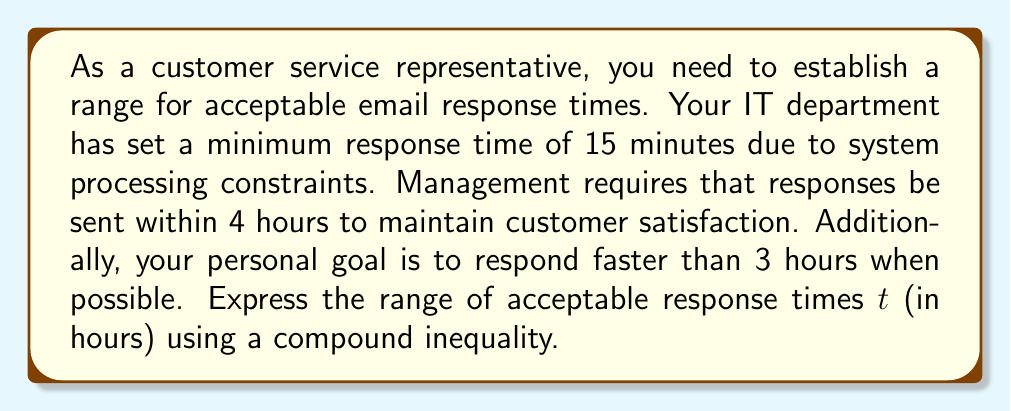Could you help me with this problem? To solve this problem, we need to convert all times to hours and then express the constraints as a compound inequality:

1. Minimum response time: 15 minutes = 0.25 hours
2. Management's maximum response time: 4 hours
3. Personal goal: less than 3 hours

The compound inequality should express that the response time $t$ is:
- Greater than or equal to 0.25 hours (IT constraint)
- Less than or equal to 4 hours (Management requirement)
- And we prefer it to be less than 3 hours (Personal goal)

We can express this as:

$$0.25 \leq t \leq 4$$

with a preference for:

$$0.25 \leq t < 3$$

The compound inequality that satisfies all conditions is:

$$0.25 \leq t < 3 \text{ or } 3 \leq t \leq 4$$

This inequality ensures that the response time is always between 0.25 and 4 hours, with a preference for it to be less than 3 hours when possible.
Answer: $$0.25 \leq t < 3 \text{ or } 3 \leq t \leq 4$$ 